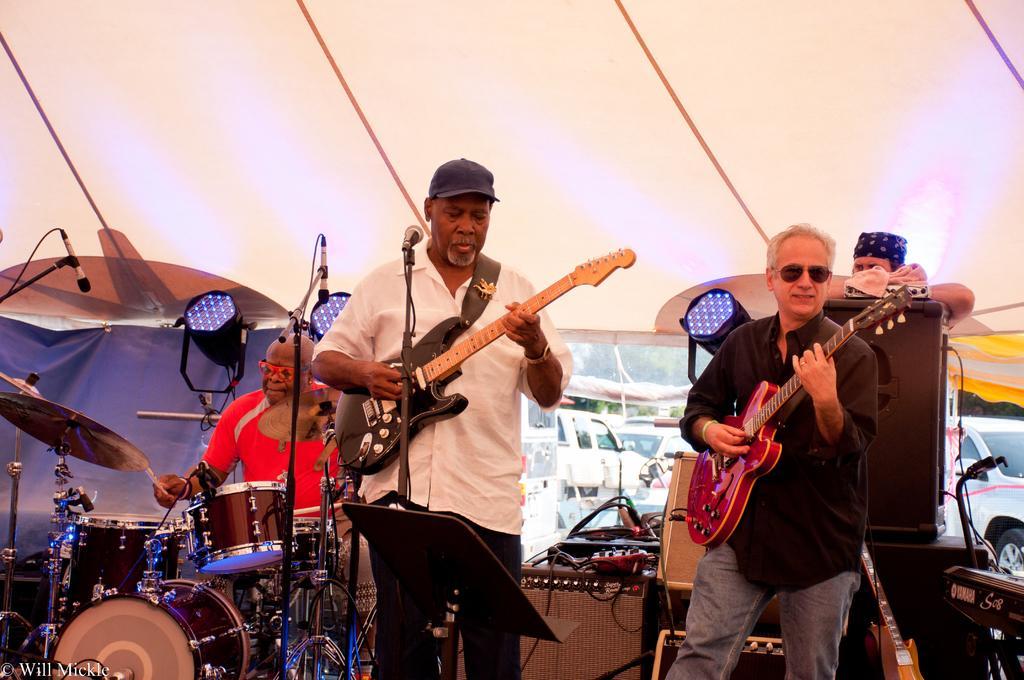How would you summarize this image in a sentence or two? A band is performing music on a stage. In the band there are two men playing guitars in the front. A man is playing drums in the background. There is a man standing behind the speakers. 